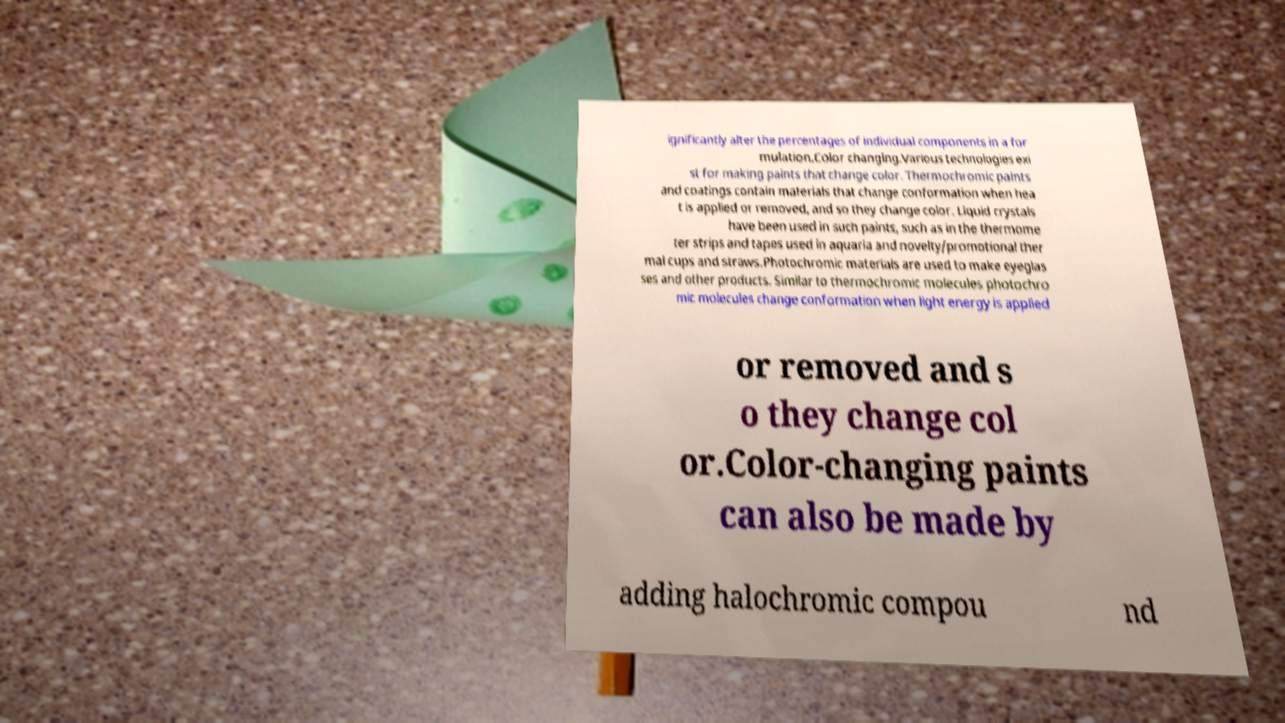Could you assist in decoding the text presented in this image and type it out clearly? ignificantly alter the percentages of individual components in a for mulation.Color changing.Various technologies exi st for making paints that change color. Thermochromic paints and coatings contain materials that change conformation when hea t is applied or removed, and so they change color. Liquid crystals have been used in such paints, such as in the thermome ter strips and tapes used in aquaria and novelty/promotional ther mal cups and straws.Photochromic materials are used to make eyeglas ses and other products. Similar to thermochromic molecules photochro mic molecules change conformation when light energy is applied or removed and s o they change col or.Color-changing paints can also be made by adding halochromic compou nd 